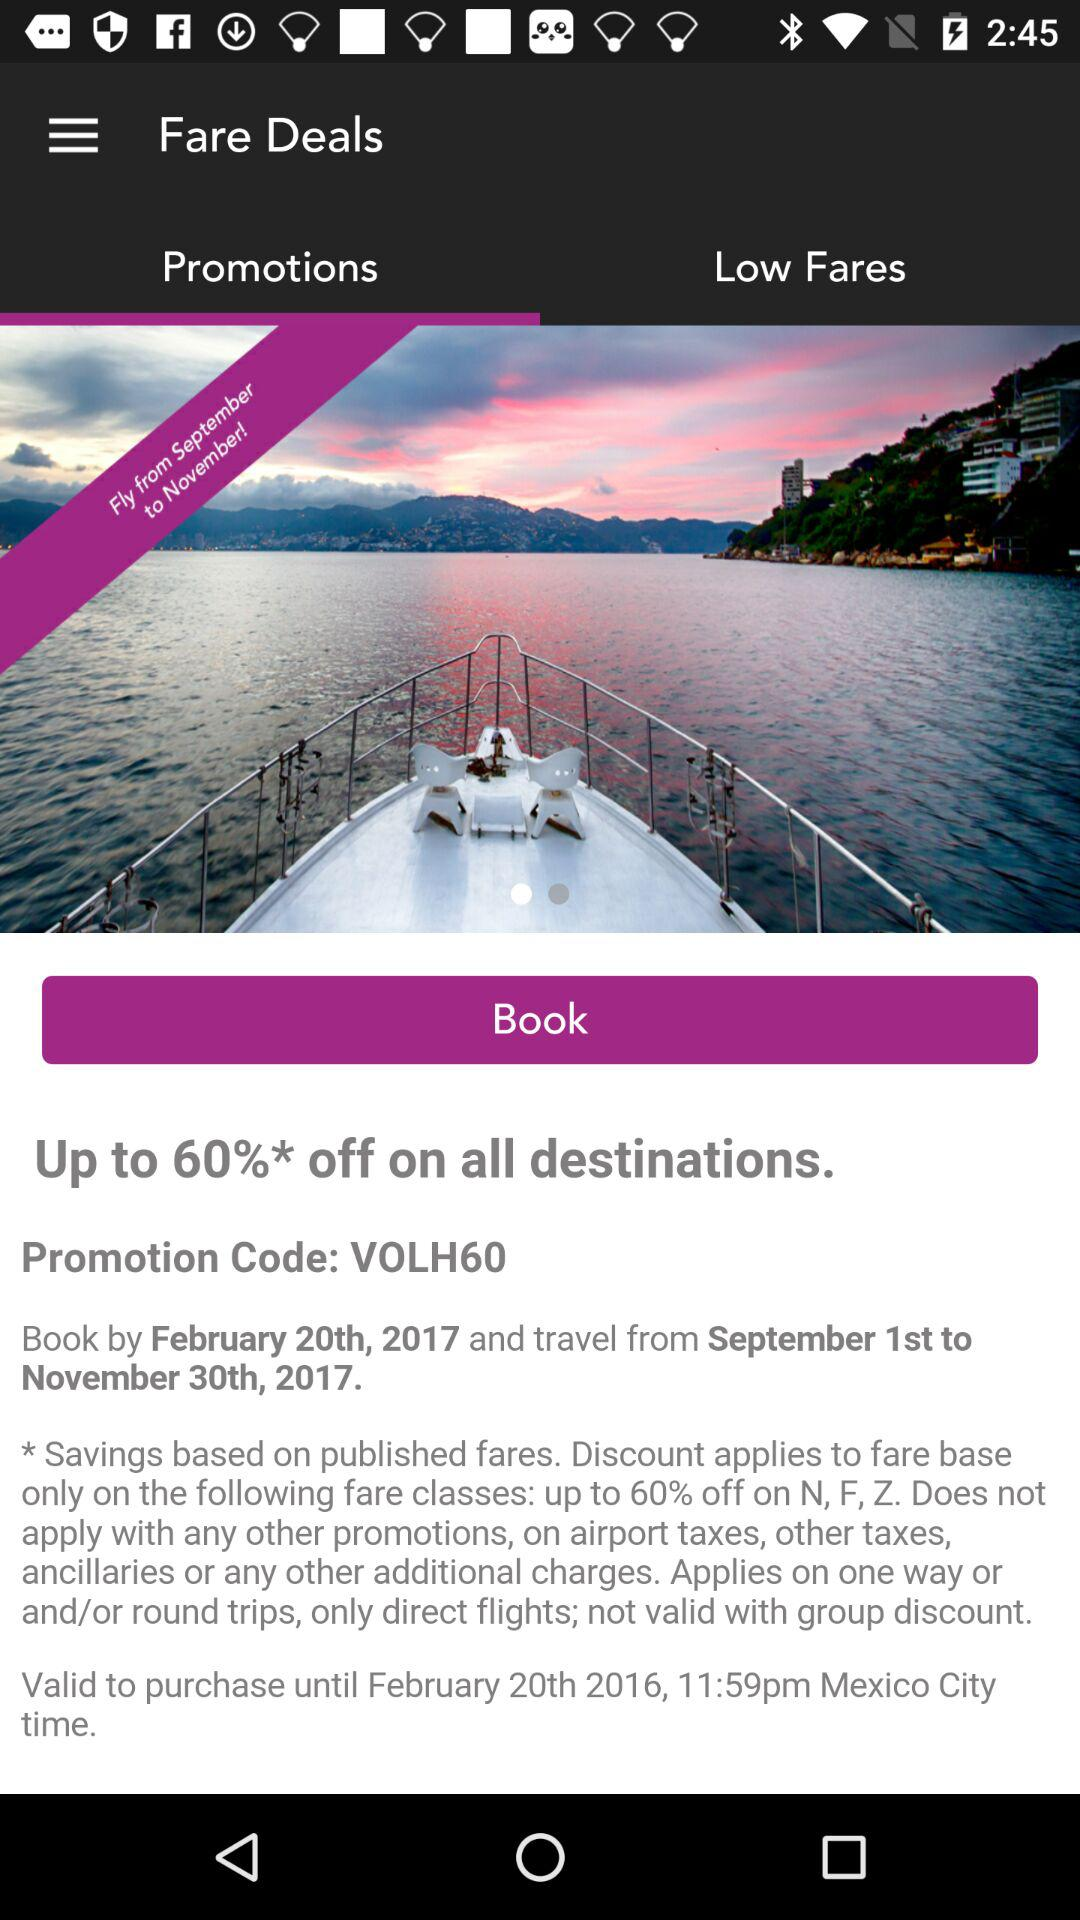Until what date and time is the deal valid in Mexico City? The deal in Mexico City is valid until February 20, 2016, 11:59 p.m. 